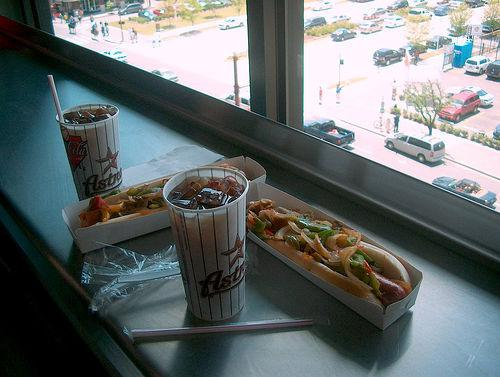What food is shown in the boats? hot dogs 